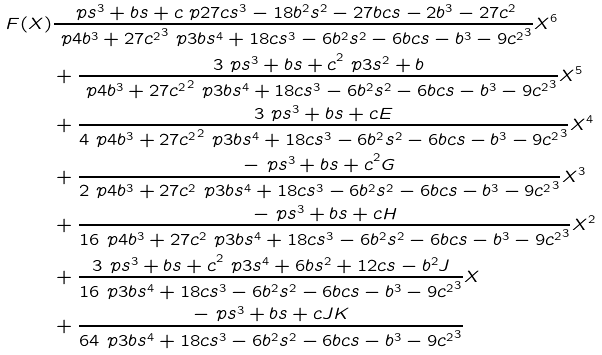<formula> <loc_0><loc_0><loc_500><loc_500>F ( X ) & \frac { \ p { s ^ { 3 } + b s + c } \ p { 2 7 c s ^ { 3 } - 1 8 b ^ { 2 } s ^ { 2 } - 2 7 b c s - 2 b ^ { 3 } - 2 7 c ^ { 2 } } } { \ p { 4 b ^ { 3 } + 2 7 c ^ { 2 } } ^ { 3 } \ p { 3 b s ^ { 4 } + 1 8 c s ^ { 3 } - 6 b ^ { 2 } s ^ { 2 } - 6 b c s - b ^ { 3 } - 9 c ^ { 2 } } ^ { 3 } } X ^ { 6 } \\ & + \frac { 3 \ p { s ^ { 3 } + b s + c } ^ { 2 } \ p { 3 s ^ { 2 } + b } } { \ p { 4 b ^ { 3 } + 2 7 c ^ { 2 } } ^ { 2 } \ p { 3 b s ^ { 4 } + 1 8 c s ^ { 3 } - 6 b ^ { 2 } s ^ { 2 } - 6 b c s - b ^ { 3 } - 9 c ^ { 2 } } ^ { 3 } } X ^ { 5 } \\ & + \frac { 3 \ p { s ^ { 3 } + b s + c } E } { 4 \ p { 4 b ^ { 3 } + 2 7 c ^ { 2 } } ^ { 2 } \ p { 3 b s ^ { 4 } + 1 8 c s ^ { 3 } - 6 b ^ { 2 } s ^ { 2 } - 6 b c s - b ^ { 3 } - 9 c ^ { 2 } } ^ { 3 } } X ^ { 4 } \\ & + \frac { - \ p { s ^ { 3 } + b s + c } ^ { 2 } G } { 2 \ p { 4 b ^ { 3 } + 2 7 c ^ { 2 } } \ p { 3 b s ^ { 4 } + 1 8 c s ^ { 3 } - 6 b ^ { 2 } s ^ { 2 } - 6 b c s - b ^ { 3 } - 9 c ^ { 2 } } ^ { 3 } } X ^ { 3 } \\ & + \frac { - \ p { s ^ { 3 } + b s + c } H } { 1 6 \ p { 4 b ^ { 3 } + 2 7 c ^ { 2 } } \ p { 3 b s ^ { 4 } + 1 8 c s ^ { 3 } - 6 b ^ { 2 } s ^ { 2 } - 6 b c s - b ^ { 3 } - 9 c ^ { 2 } } ^ { 3 } } X ^ { 2 } \\ & + \frac { 3 \ p { s ^ { 3 } + b s + c } ^ { 2 } \ p { 3 s ^ { 4 } + 6 b s ^ { 2 } + 1 2 c s - b ^ { 2 } } J } { 1 6 \ p { 3 b s ^ { 4 } + 1 8 c s ^ { 3 } - 6 b ^ { 2 } s ^ { 2 } - 6 b c s - b ^ { 3 } - 9 c ^ { 2 } } ^ { 3 } } X \\ & + \frac { - \ p { s ^ { 3 } + b s + c } J K } { 6 4 \ p { 3 b s ^ { 4 } + 1 8 c s ^ { 3 } - 6 b ^ { 2 } s ^ { 2 } - 6 b c s - b ^ { 3 } - 9 c ^ { 2 } } ^ { 3 } }</formula> 